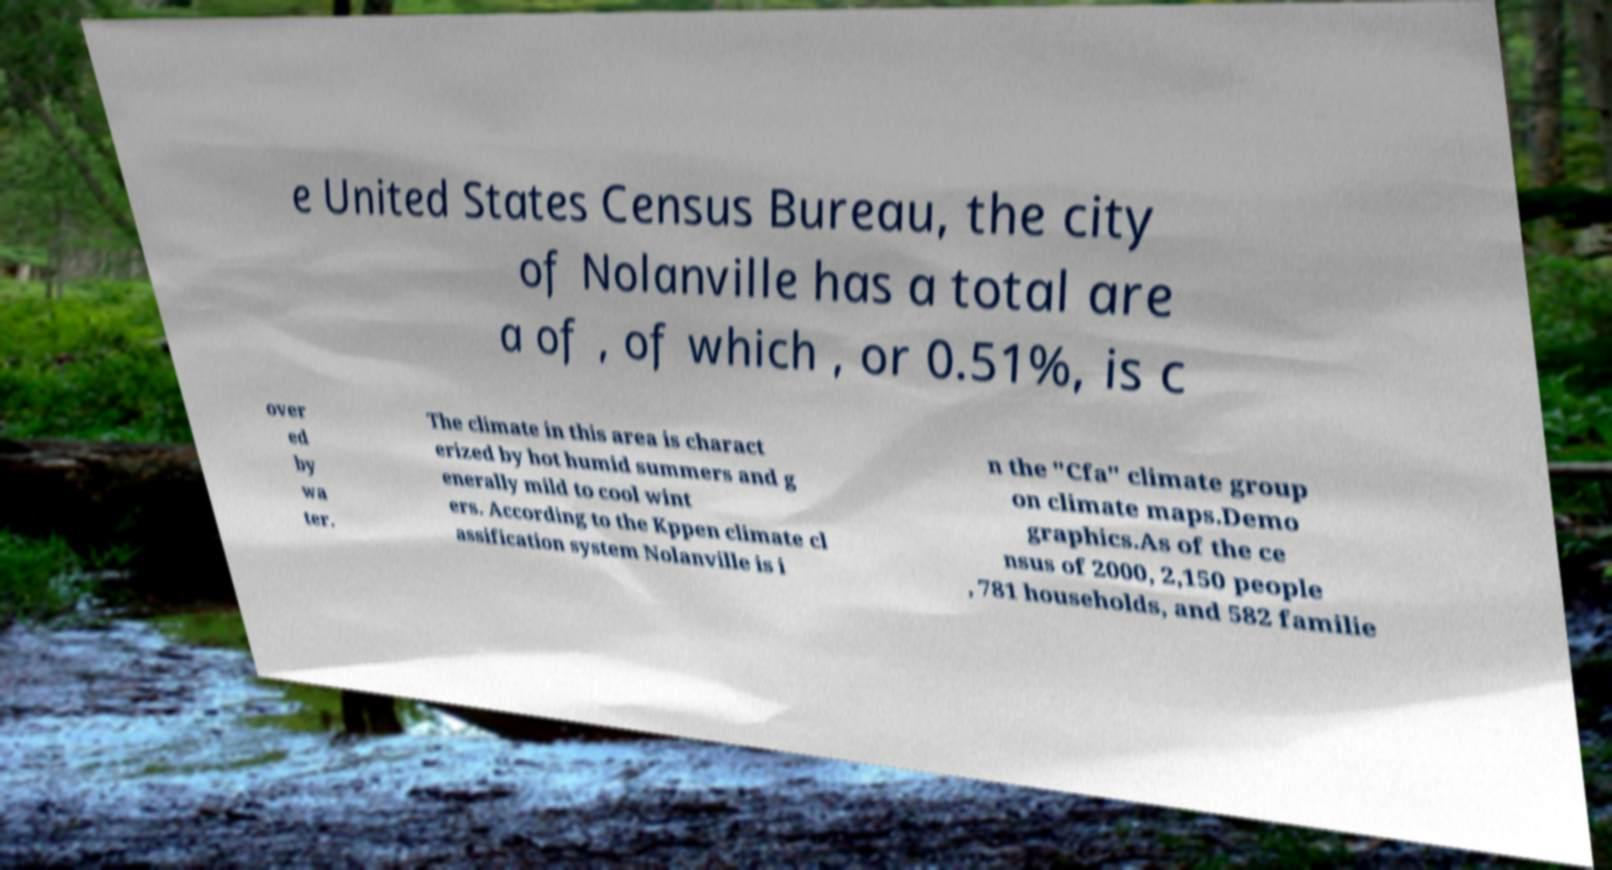What messages or text are displayed in this image? I need them in a readable, typed format. e United States Census Bureau, the city of Nolanville has a total are a of , of which , or 0.51%, is c over ed by wa ter. The climate in this area is charact erized by hot humid summers and g enerally mild to cool wint ers. According to the Kppen climate cl assification system Nolanville is i n the "Cfa" climate group on climate maps.Demo graphics.As of the ce nsus of 2000, 2,150 people , 781 households, and 582 familie 